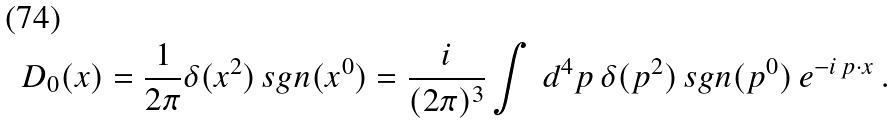Convert formula to latex. <formula><loc_0><loc_0><loc_500><loc_500>D _ { 0 } ( x ) = \frac { 1 } { 2 \pi } \delta ( x ^ { 2 } ) \, s g n ( x ^ { 0 } ) = \frac { i } { ( 2 \pi ) ^ { 3 } } \int \, d ^ { 4 } p \, \delta ( p ^ { 2 } ) \, s g n ( p ^ { 0 } ) \, e ^ { - i \, p \cdot x } \, .</formula> 